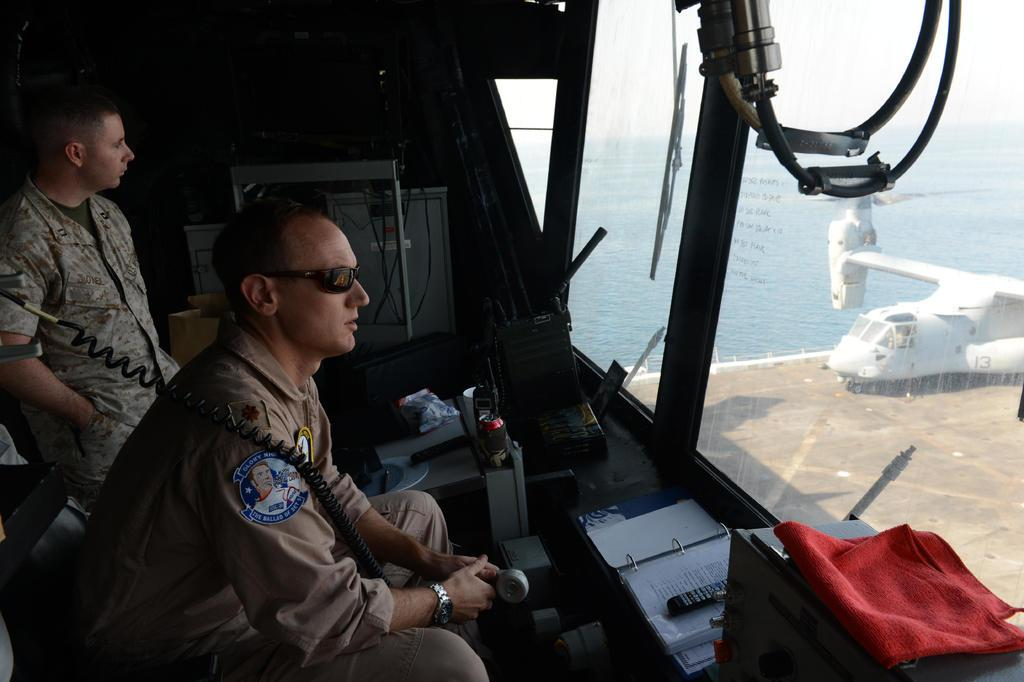What is the primary element visible in the image? There is water in the image. What type of vehicle can be seen in the image? There is a plane in the image. What objects related to reading can be found in the image? There are books in the image. What device is present for controlling electronic devices? There is a remote in the image. What material is present in the image that can be used for various purposes? There is cloth in the image. What communication device is visible in the image? There is a phone in the image. What type of people are present in the image? There are two people wearing army dresses in the image. What type of celery is being used as a prop in the image? There is no celery present in the image. What scientific experiment is being conducted in the image? The image does not depict a scientific experiment; it contains a plane, water, books, a remote, cloth, a phone, and two people in army dresses. 